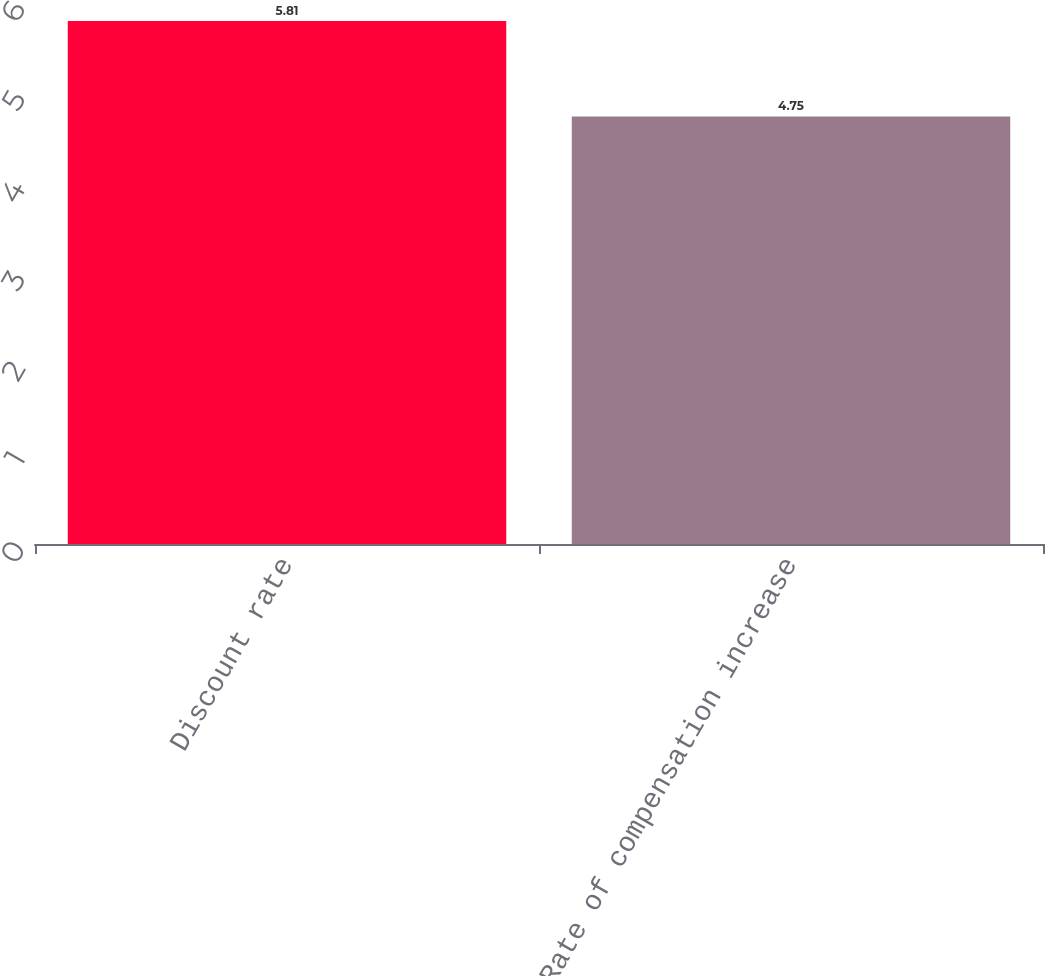Convert chart. <chart><loc_0><loc_0><loc_500><loc_500><bar_chart><fcel>Discount rate<fcel>Rate of compensation increase<nl><fcel>5.81<fcel>4.75<nl></chart> 